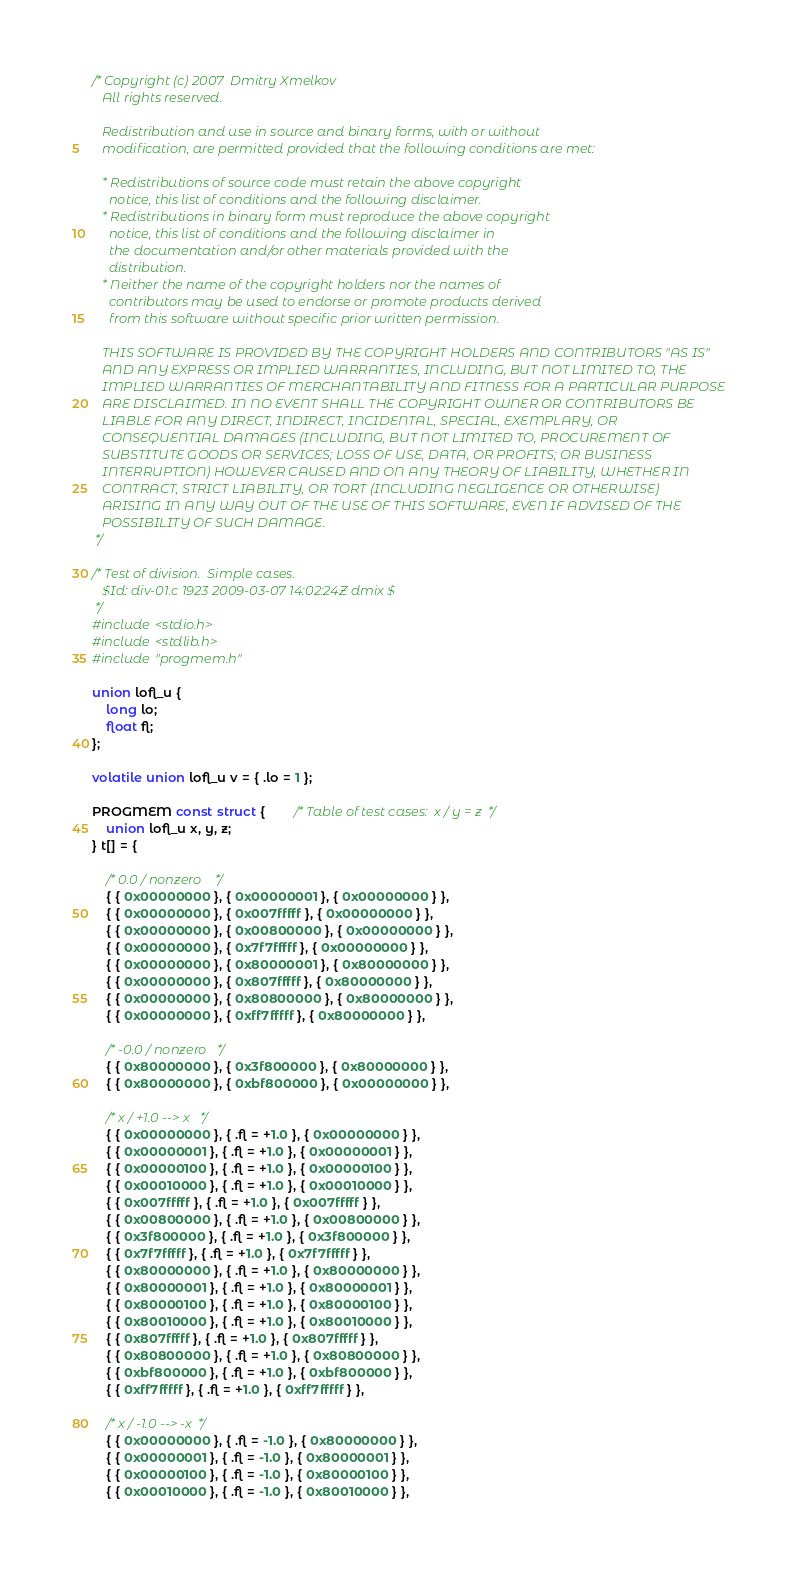Convert code to text. <code><loc_0><loc_0><loc_500><loc_500><_C_>/* Copyright (c) 2007  Dmitry Xmelkov
   All rights reserved.

   Redistribution and use in source and binary forms, with or without
   modification, are permitted provided that the following conditions are met:

   * Redistributions of source code must retain the above copyright
     notice, this list of conditions and the following disclaimer.
   * Redistributions in binary form must reproduce the above copyright
     notice, this list of conditions and the following disclaimer in
     the documentation and/or other materials provided with the
     distribution.
   * Neither the name of the copyright holders nor the names of
     contributors may be used to endorse or promote products derived
     from this software without specific prior written permission.

   THIS SOFTWARE IS PROVIDED BY THE COPYRIGHT HOLDERS AND CONTRIBUTORS "AS IS"
   AND ANY EXPRESS OR IMPLIED WARRANTIES, INCLUDING, BUT NOT LIMITED TO, THE
   IMPLIED WARRANTIES OF MERCHANTABILITY AND FITNESS FOR A PARTICULAR PURPOSE
   ARE DISCLAIMED. IN NO EVENT SHALL THE COPYRIGHT OWNER OR CONTRIBUTORS BE
   LIABLE FOR ANY DIRECT, INDIRECT, INCIDENTAL, SPECIAL, EXEMPLARY, OR
   CONSEQUENTIAL DAMAGES (INCLUDING, BUT NOT LIMITED TO, PROCUREMENT OF
   SUBSTITUTE GOODS OR SERVICES; LOSS OF USE, DATA, OR PROFITS; OR BUSINESS
   INTERRUPTION) HOWEVER CAUSED AND ON ANY THEORY OF LIABILITY, WHETHER IN
   CONTRACT, STRICT LIABILITY, OR TORT (INCLUDING NEGLIGENCE OR OTHERWISE)
   ARISING IN ANY WAY OUT OF THE USE OF THIS SOFTWARE, EVEN IF ADVISED OF THE
   POSSIBILITY OF SUCH DAMAGE.
 */

/* Test of division.  Simple cases.
   $Id: div-01.c 1923 2009-03-07 14:02:24Z dmix $
 */
#include <stdio.h>
#include <stdlib.h>
#include "progmem.h"

union lofl_u {
    long lo;
    float fl;
};

volatile union lofl_u v = { .lo = 1 };

PROGMEM const struct {		/* Table of test cases:  x / y = z	*/
    union lofl_u x, y, z;
} t[] = {

    /* 0.0 / nonzero	*/
    { { 0x00000000 }, { 0x00000001 }, { 0x00000000 } },
    { { 0x00000000 }, { 0x007fffff }, { 0x00000000 } },
    { { 0x00000000 }, { 0x00800000 }, { 0x00000000 } },
    { { 0x00000000 }, { 0x7f7fffff }, { 0x00000000 } },
    { { 0x00000000 }, { 0x80000001 }, { 0x80000000 } },
    { { 0x00000000 }, { 0x807fffff }, { 0x80000000 } },
    { { 0x00000000 }, { 0x80800000 }, { 0x80000000 } },
    { { 0x00000000 }, { 0xff7fffff }, { 0x80000000 } },

    /* -0.0 / nonzero	*/
    { { 0x80000000 }, { 0x3f800000 }, { 0x80000000 } },
    { { 0x80000000 }, { 0xbf800000 }, { 0x00000000 } },

    /* x / +1.0	--> x	*/
    { { 0x00000000 }, { .fl = +1.0 }, { 0x00000000 } },
    { { 0x00000001 }, { .fl = +1.0 }, { 0x00000001 } },
    { { 0x00000100 }, { .fl = +1.0 }, { 0x00000100 } },
    { { 0x00010000 }, { .fl = +1.0 }, { 0x00010000 } },
    { { 0x007fffff }, { .fl = +1.0 }, { 0x007fffff } },
    { { 0x00800000 }, { .fl = +1.0 }, { 0x00800000 } },
    { { 0x3f800000 }, { .fl = +1.0 }, { 0x3f800000 } },
    { { 0x7f7fffff }, { .fl = +1.0 }, { 0x7f7fffff } },
    { { 0x80000000 }, { .fl = +1.0 }, { 0x80000000 } },
    { { 0x80000001 }, { .fl = +1.0 }, { 0x80000001 } },
    { { 0x80000100 }, { .fl = +1.0 }, { 0x80000100 } },
    { { 0x80010000 }, { .fl = +1.0 }, { 0x80010000 } },
    { { 0x807fffff }, { .fl = +1.0 }, { 0x807fffff } },
    { { 0x80800000 }, { .fl = +1.0 }, { 0x80800000 } },
    { { 0xbf800000 }, { .fl = +1.0 }, { 0xbf800000 } },
    { { 0xff7fffff }, { .fl = +1.0 }, { 0xff7fffff } },

    /* x / -1.0	--> -x	*/
    { { 0x00000000 }, { .fl = -1.0 }, { 0x80000000 } },
    { { 0x00000001 }, { .fl = -1.0 }, { 0x80000001 } },
    { { 0x00000100 }, { .fl = -1.0 }, { 0x80000100 } },
    { { 0x00010000 }, { .fl = -1.0 }, { 0x80010000 } },</code> 